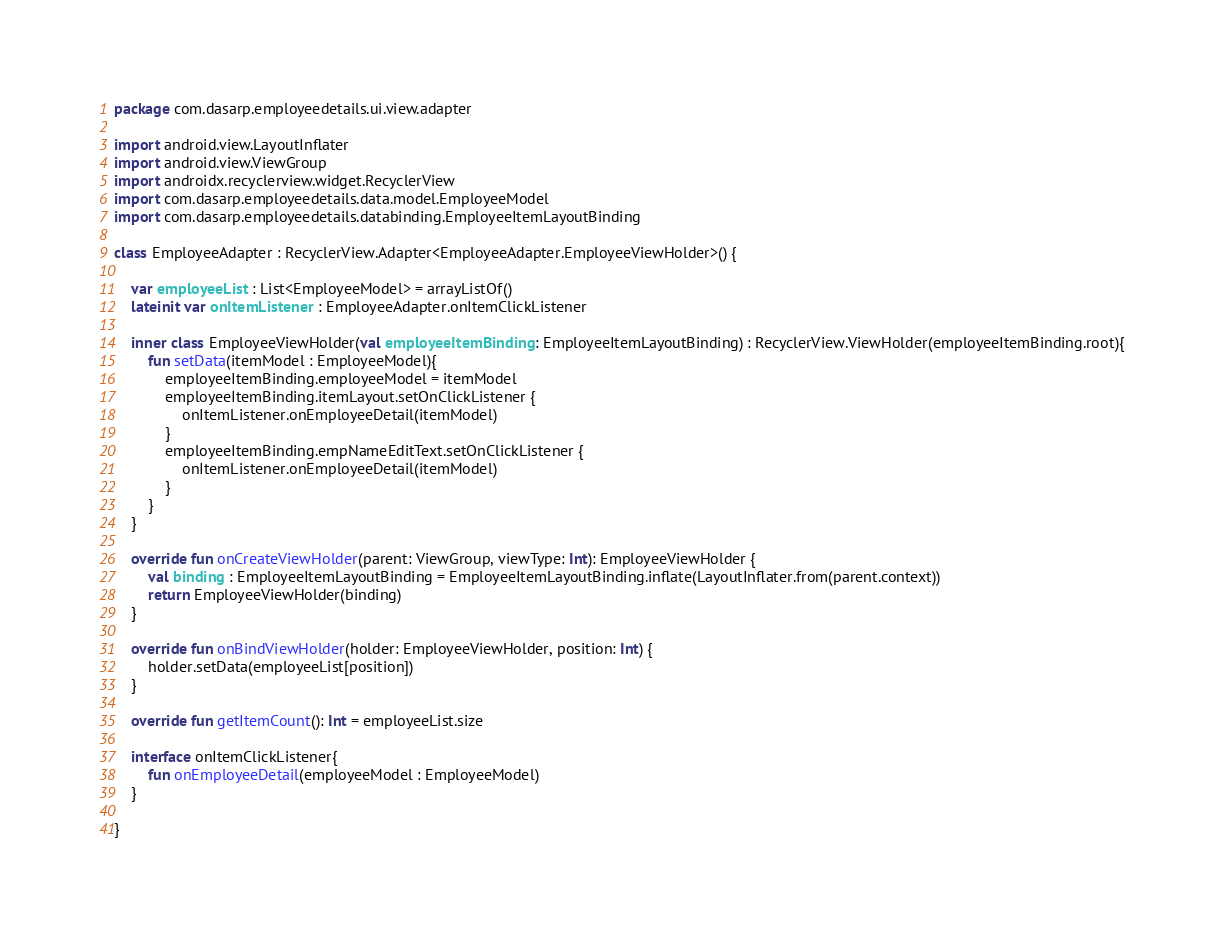Convert code to text. <code><loc_0><loc_0><loc_500><loc_500><_Kotlin_>package com.dasarp.employeedetails.ui.view.adapter

import android.view.LayoutInflater
import android.view.ViewGroup
import androidx.recyclerview.widget.RecyclerView
import com.dasarp.employeedetails.data.model.EmployeeModel
import com.dasarp.employeedetails.databinding.EmployeeItemLayoutBinding

class EmployeeAdapter : RecyclerView.Adapter<EmployeeAdapter.EmployeeViewHolder>() {

    var employeeList : List<EmployeeModel> = arrayListOf()
    lateinit var onItemListener : EmployeeAdapter.onItemClickListener

    inner class EmployeeViewHolder(val employeeItemBinding: EmployeeItemLayoutBinding) : RecyclerView.ViewHolder(employeeItemBinding.root){
        fun setData(itemModel : EmployeeModel){
            employeeItemBinding.employeeModel = itemModel
            employeeItemBinding.itemLayout.setOnClickListener {
                onItemListener.onEmployeeDetail(itemModel)
            }
            employeeItemBinding.empNameEditText.setOnClickListener {
                onItemListener.onEmployeeDetail(itemModel)
            }
        }
    }

    override fun onCreateViewHolder(parent: ViewGroup, viewType: Int): EmployeeViewHolder {
        val binding : EmployeeItemLayoutBinding = EmployeeItemLayoutBinding.inflate(LayoutInflater.from(parent.context))
        return EmployeeViewHolder(binding)
    }

    override fun onBindViewHolder(holder: EmployeeViewHolder, position: Int) {
        holder.setData(employeeList[position])
    }

    override fun getItemCount(): Int = employeeList.size

    interface onItemClickListener{
        fun onEmployeeDetail(employeeModel : EmployeeModel)
    }

}</code> 